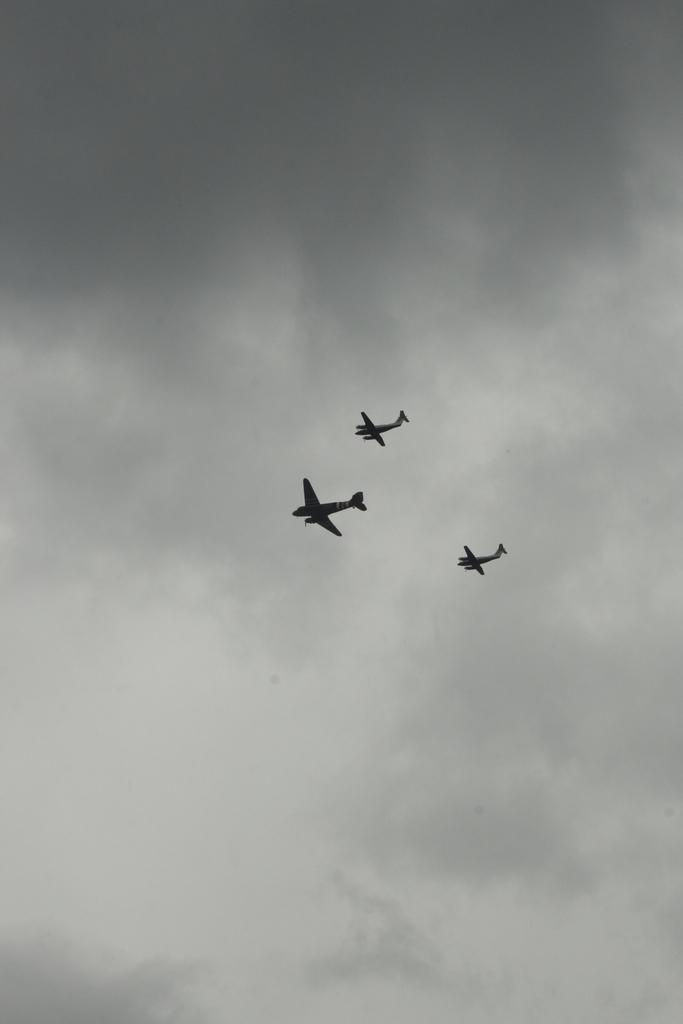What is the main subject of the image? The main subject of the image is aeroplanes in the air. Where are the aeroplanes located in the image? The aeroplanes are in the center of the image. What can be seen in the background of the image? There is sky visible in the background of the image. What is present in the sky? There are clouds in the sky. What type of stem can be seen growing from the clouds in the image? There is no stem growing from the clouds in the image. What does the dad say about the aeroplanes in the image? There is no dad present in the image, so it is not possible to answer this question. 